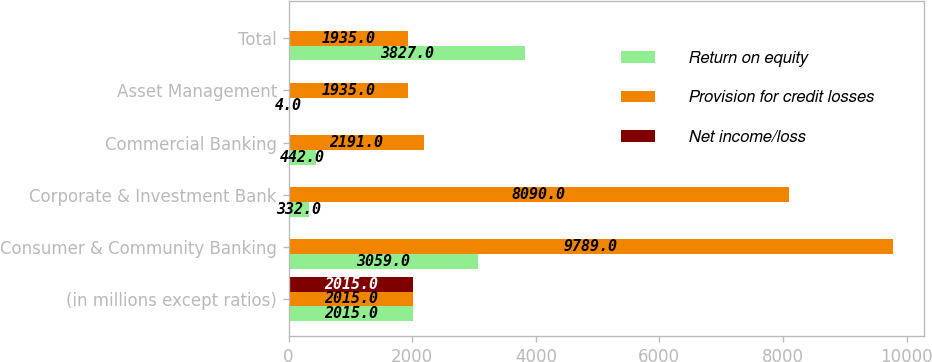<chart> <loc_0><loc_0><loc_500><loc_500><stacked_bar_chart><ecel><fcel>(in millions except ratios)<fcel>Consumer & Community Banking<fcel>Corporate & Investment Bank<fcel>Commercial Banking<fcel>Asset Management<fcel>Total<nl><fcel>Return on equity<fcel>2015<fcel>3059<fcel>332<fcel>442<fcel>4<fcel>3827<nl><fcel>Provision for credit losses<fcel>2015<fcel>9789<fcel>8090<fcel>2191<fcel>1935<fcel>1935<nl><fcel>Net income/loss<fcel>2015<fcel>18<fcel>12<fcel>15<fcel>21<fcel>11<nl></chart> 